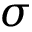Convert formula to latex. <formula><loc_0><loc_0><loc_500><loc_500>\sigma</formula> 